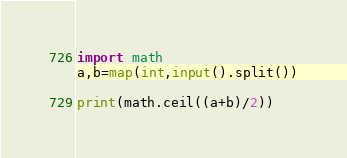<code> <loc_0><loc_0><loc_500><loc_500><_Python_>import math
a,b=map(int,input().split())

print(math.ceil((a+b)/2))</code> 